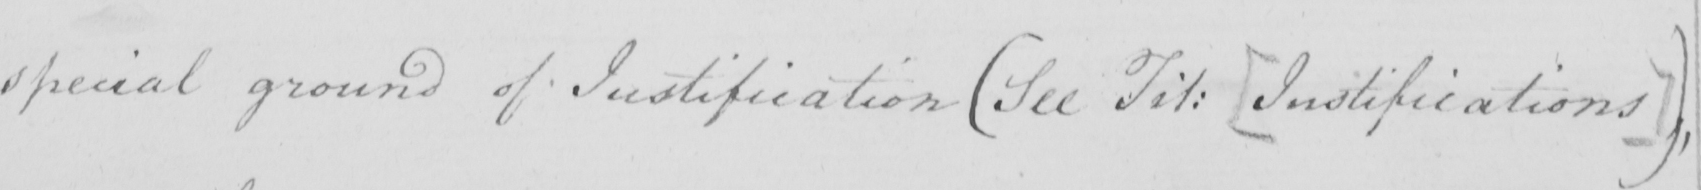Transcribe the text shown in this historical manuscript line. special ground of justification  ( See Fit :   [ Justifications ]  )  , 